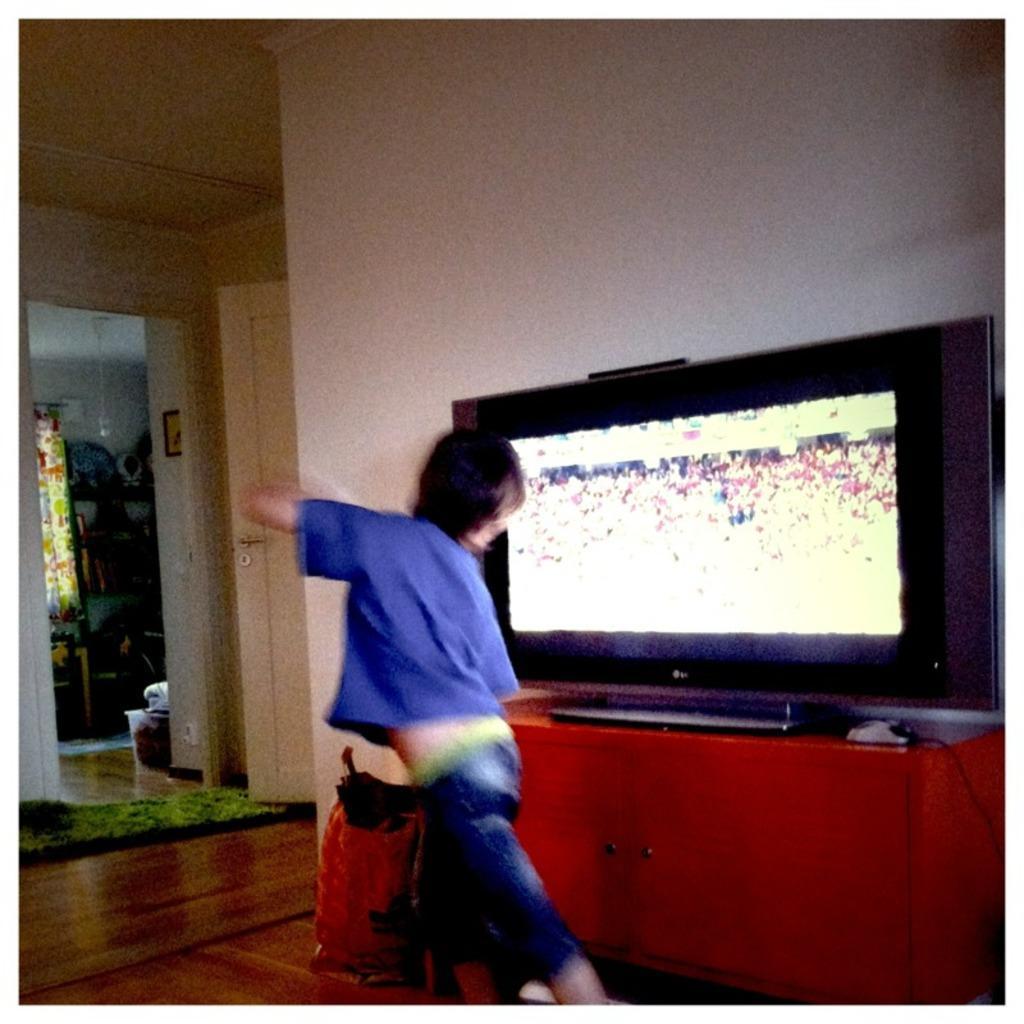Can you describe this image briefly? This is a picture of inside of the house, in this image in the center there is one boy who is standing. In front of him there is a television on the table, and on the left side there is a door, curtain, window and on the wall there are some photo frames and some objects. At the bottom there is a floor, on the floor there is a carpet and at the top there is ceiling. 